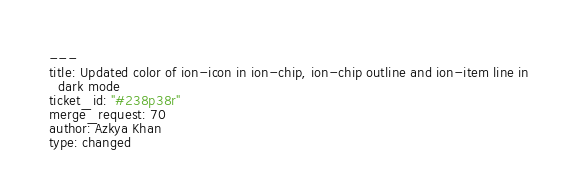<code> <loc_0><loc_0><loc_500><loc_500><_YAML_>---
title: Updated color of ion-icon in ion-chip, ion-chip outline and ion-item line in
  dark mode
ticket_id: "#238p38r"
merge_request: 70
author: Azkya Khan
type: changed
</code> 